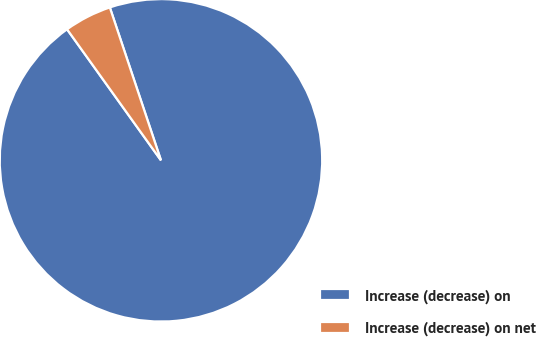<chart> <loc_0><loc_0><loc_500><loc_500><pie_chart><fcel>Increase (decrease) on<fcel>Increase (decrease) on net<nl><fcel>95.24%<fcel>4.76%<nl></chart> 